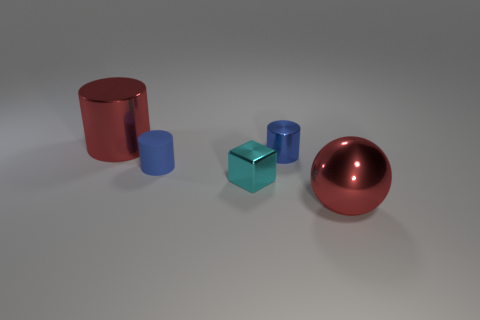Add 4 tiny rubber cylinders. How many objects exist? 9 Subtract all blue cylinders. Subtract all gray cubes. How many cylinders are left? 1 Subtract all spheres. How many objects are left? 4 Subtract all purple spheres. Subtract all metallic blocks. How many objects are left? 4 Add 1 rubber cylinders. How many rubber cylinders are left? 2 Add 5 red objects. How many red objects exist? 7 Subtract 0 brown spheres. How many objects are left? 5 